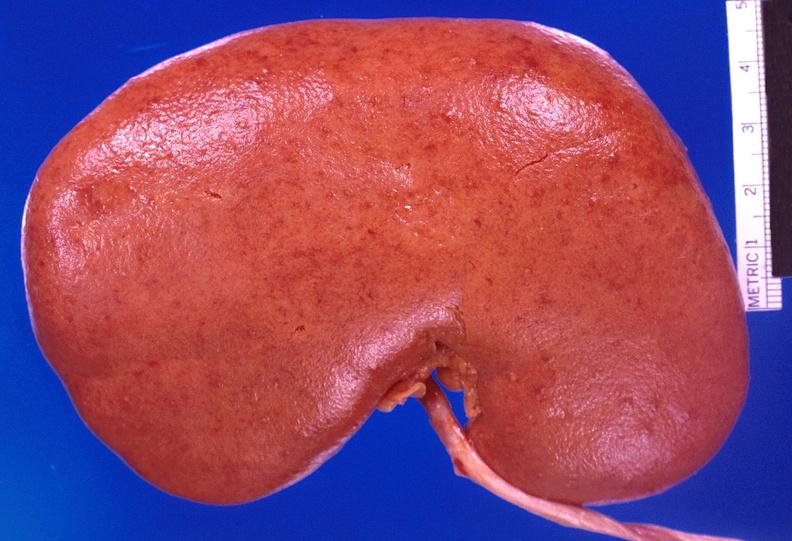where is this?
Answer the question using a single word or phrase. Urinary 